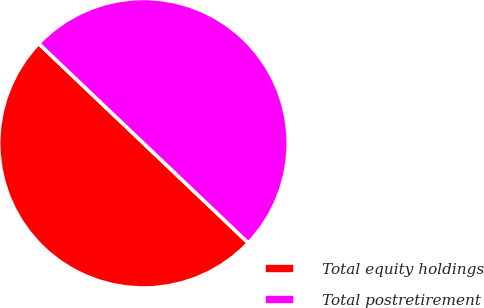Convert chart to OTSL. <chart><loc_0><loc_0><loc_500><loc_500><pie_chart><fcel>Total equity holdings<fcel>Total postretirement<nl><fcel>50.0%<fcel>50.0%<nl></chart> 